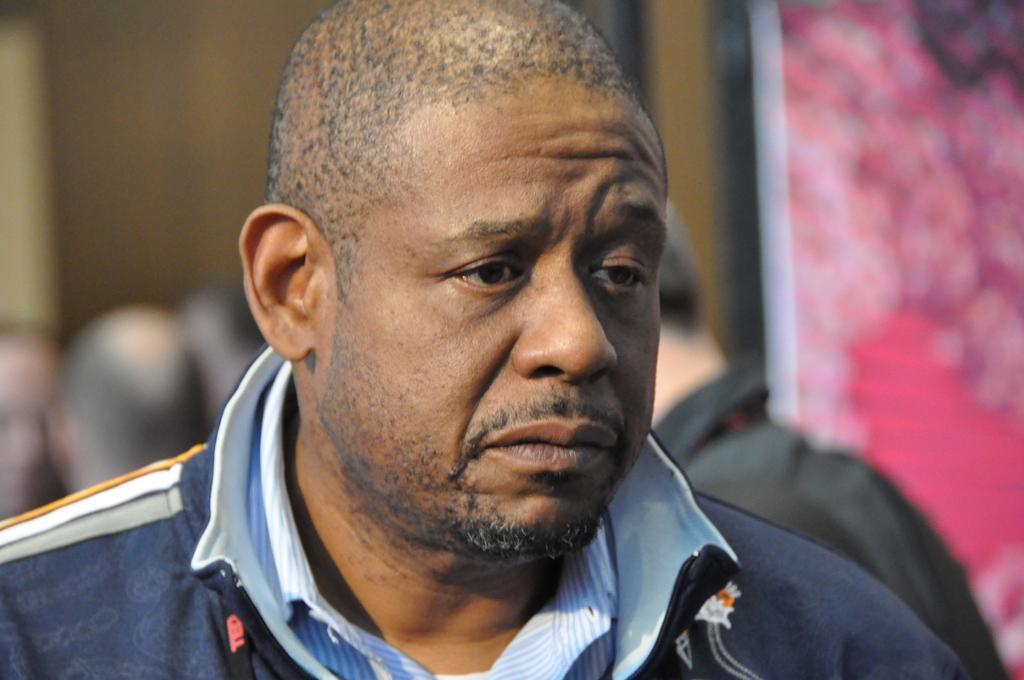What is the main subject in the foreground of the image? There is a person in the foreground of the image. Can you describe the scene in the background? There are people visible in the background of the image, and there is a wall in the background as well. What can be said about the wall on the right side? The wall on the right side might be colorful. How many plates are stacked on the ball in the image? There is no ball or plates present in the image. 